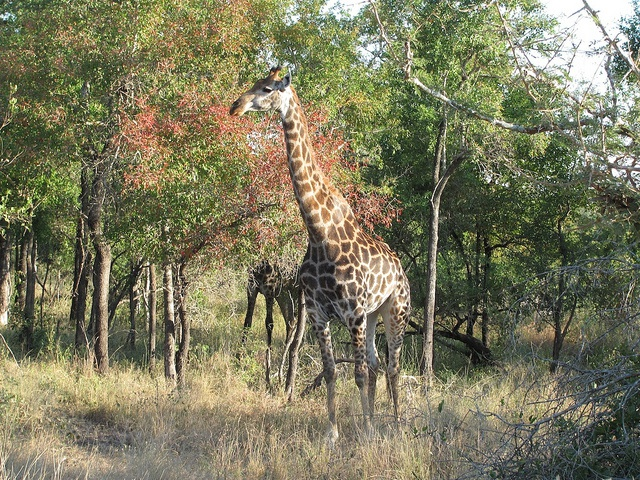Describe the objects in this image and their specific colors. I can see giraffe in darkgreen, gray, black, ivory, and tan tones and giraffe in darkgreen, black, gray, and tan tones in this image. 